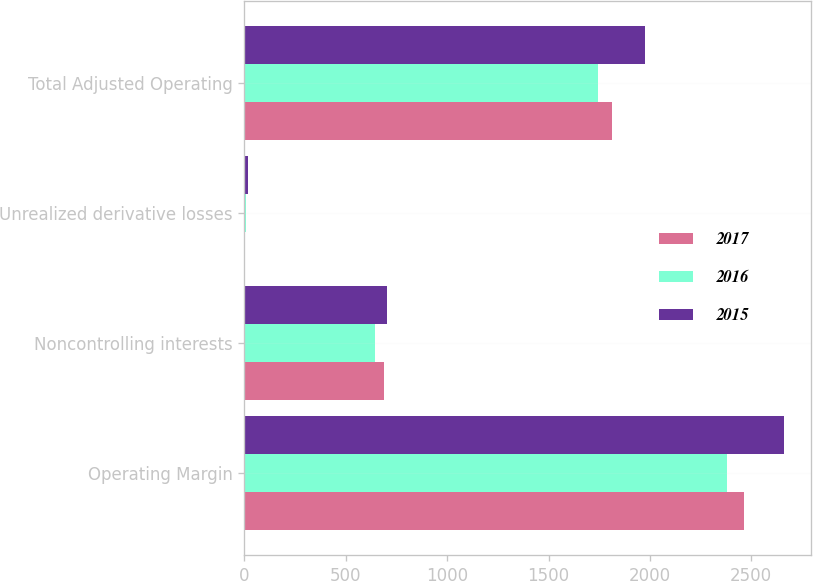Convert chart to OTSL. <chart><loc_0><loc_0><loc_500><loc_500><stacked_bar_chart><ecel><fcel>Operating Margin<fcel>Noncontrolling interests<fcel>Unrealized derivative losses<fcel>Total Adjusted Operating<nl><fcel>2017<fcel>2464<fcel>690<fcel>5<fcel>1813<nl><fcel>2016<fcel>2380<fcel>644<fcel>9<fcel>1745<nl><fcel>2015<fcel>2663<fcel>705<fcel>19<fcel>1977<nl></chart> 